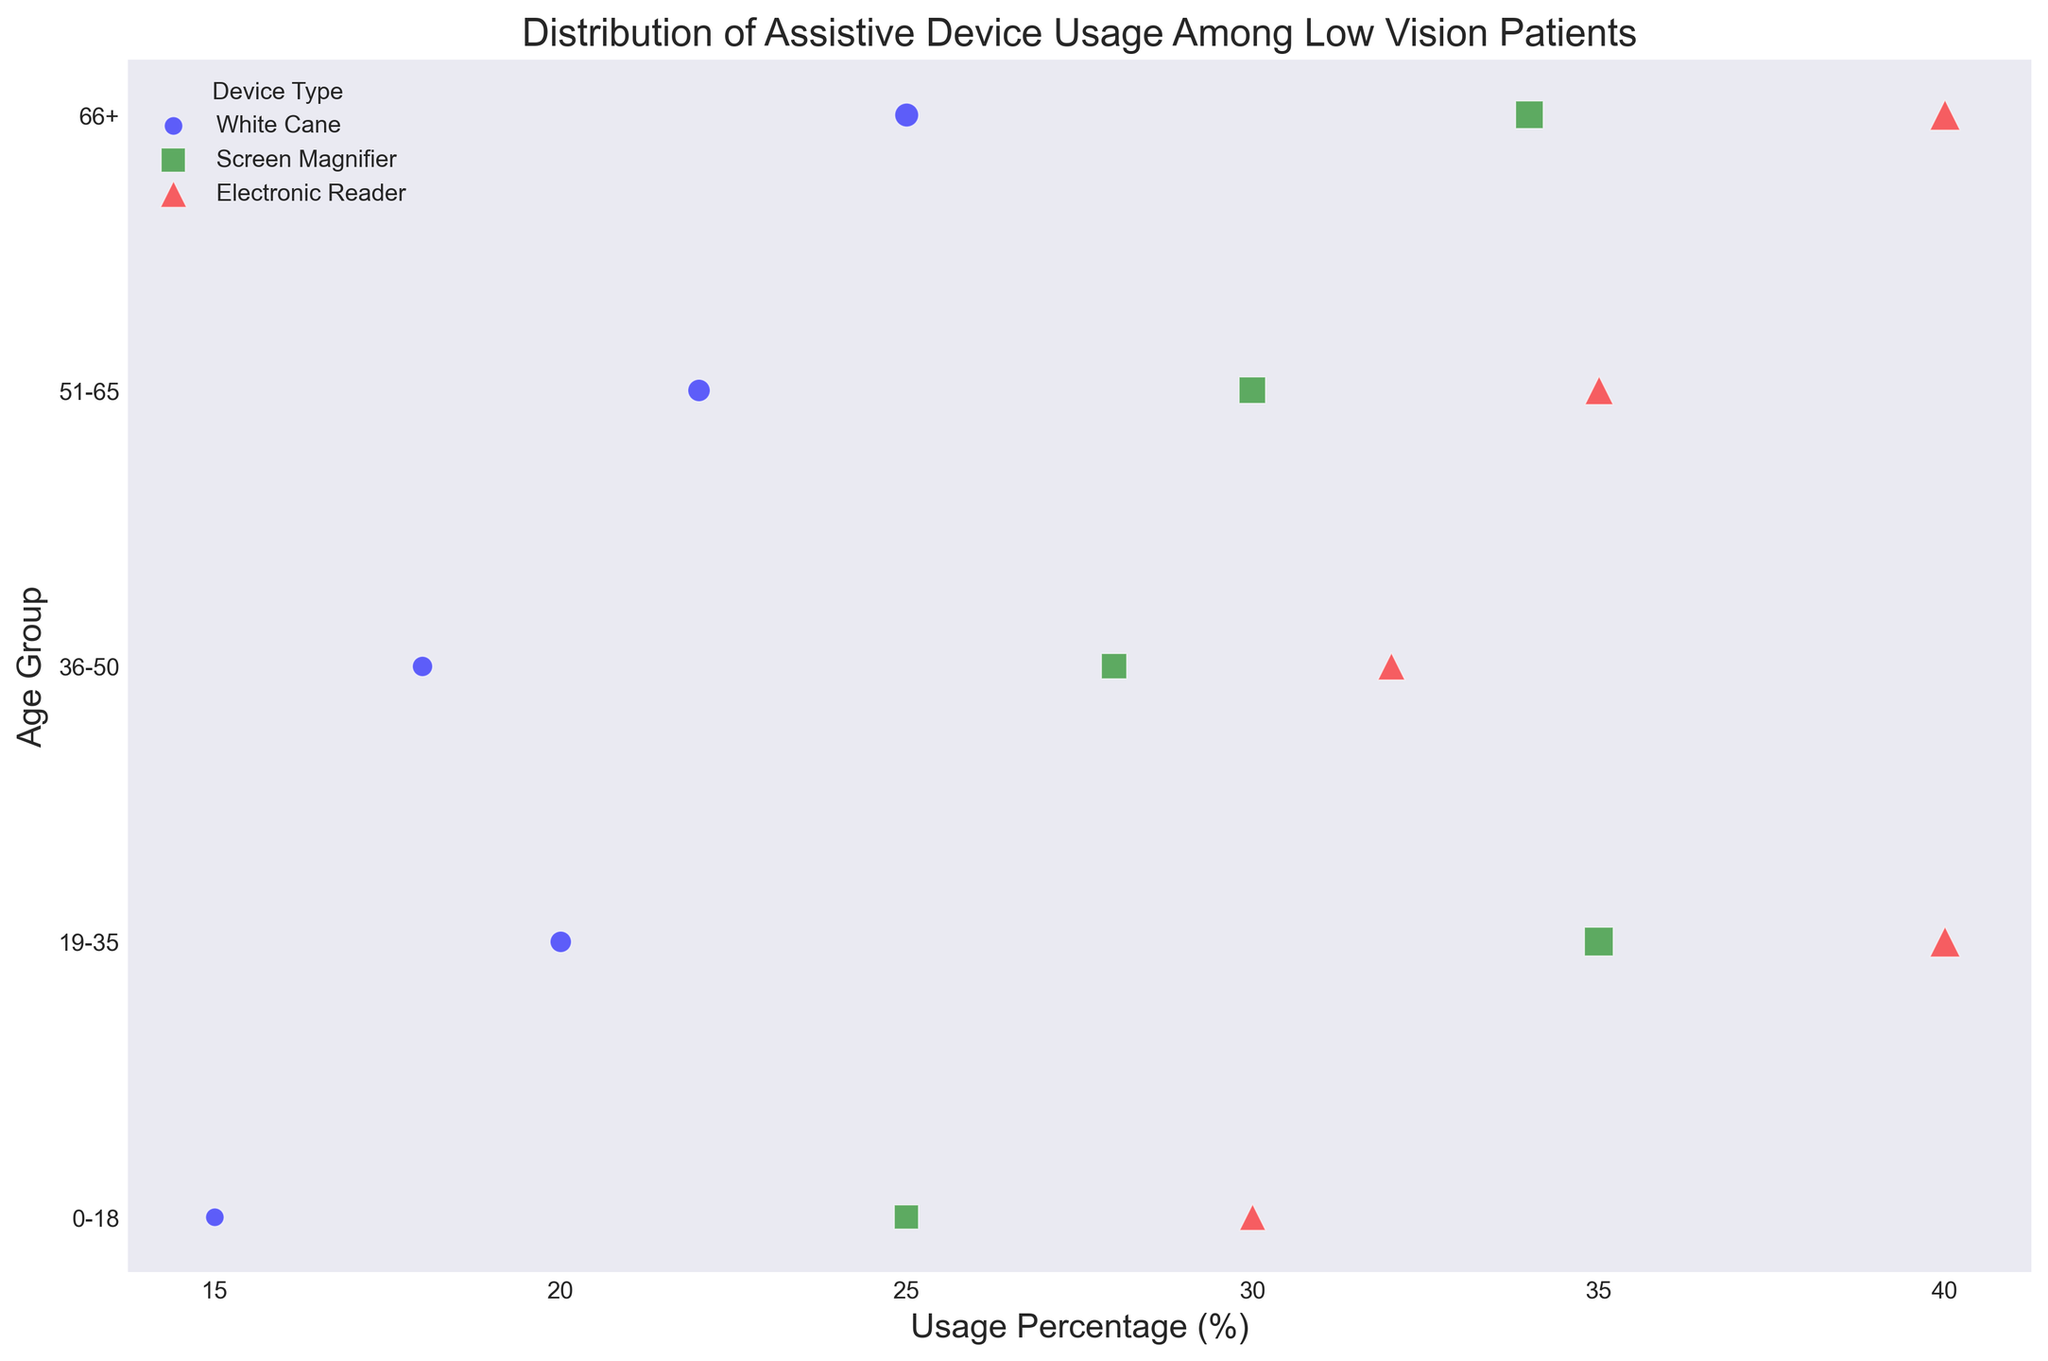What is the device with the highest usage percentage among the 19-35 age group? In the 19-35 age group, compare the usage percentages of each device. The White Cane has 20%, the Screen Magnifier has 35%, and the Electronic Reader has 40%. So, the Electronic Reader has the highest usage percentage.
Answer: Electronic Reader Which age group has the smallest bubble for White Cane use? The smallest bubble size represents the least number of patients using that device. By scanning the figure, 0-18 age group has the smallest bubble size for White Cane use (15% and 30 patients).
Answer: 0-18 Compare the usage percentage of Screen Magnifier between the 36-50 and 66+ age groups. Which one has greater use? Look at the usage percentages of the Screen Magnifier in the two age groups. The 36-50 age group has 28%, and the 66+ age group has 34%. So, the 66+ age group has greater use.
Answer: 66+ What is the cumulative number of patients using Electronic Readers in the combined age groups 19-35 and 51-65? Sum the patient counts for Electronic Reader in the 19-35 (80) and 51-65 (70) age groups: 80 + 70 = 150.
Answer: 150 Which device type uses red markers in the plot? By identifying the color red in the legend, we can see that it is associated with the Electronic Reader.
Answer: Electronic Reader Calculate the average usage percentage of the Screen Magnifier across all age groups. Add the usage percentages for Screen Magnifier in all age groups: 25 + 35 + 28 + 30 + 34 = 152. Then divide by the number of age groups (5): 152 / 5 = 30.4%.
Answer: 30.4% Identify the range of usage percentages for White Cane use across different age groups. The usage percentages for White Cane in different age groups are: 0-18 (15%), 19-35 (20%), 36-50 (18%), 51-65 (22%), and 66+ (25%). The range is thus from 15% to 25%.
Answer: 15% to 25% What is the total number of patients across all age groups using the Screen Magnifier? Sum the patient counts for Screen Magnifier in each age group: 50 + 70 + 56 + 60 + 68 = 304.
Answer: 304 Compare the bubble sizes for White Cane and Electronic Reader in the 0-18 age group. Which has a larger patient count? The bubble size represents the patient count. The White Cane has 30 patients, while the Electronic Reader has 60 patients. Therefore, the Electronic Reader has a larger patient count.
Answer: Electronic Reader 